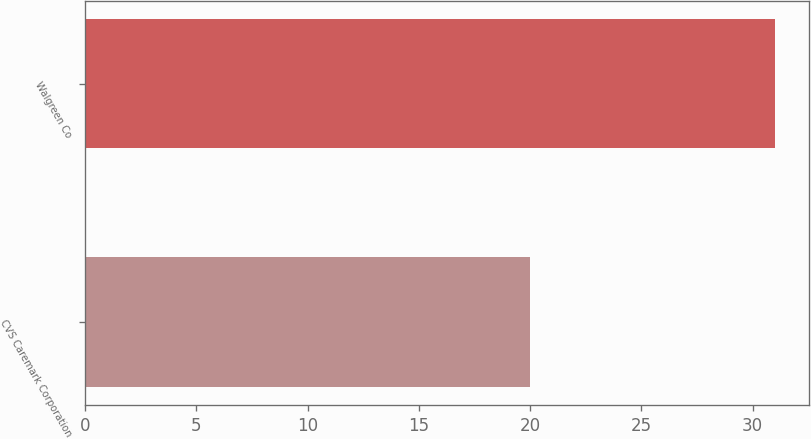Convert chart. <chart><loc_0><loc_0><loc_500><loc_500><bar_chart><fcel>CVS Caremark Corporation<fcel>Walgreen Co<nl><fcel>20<fcel>31<nl></chart> 